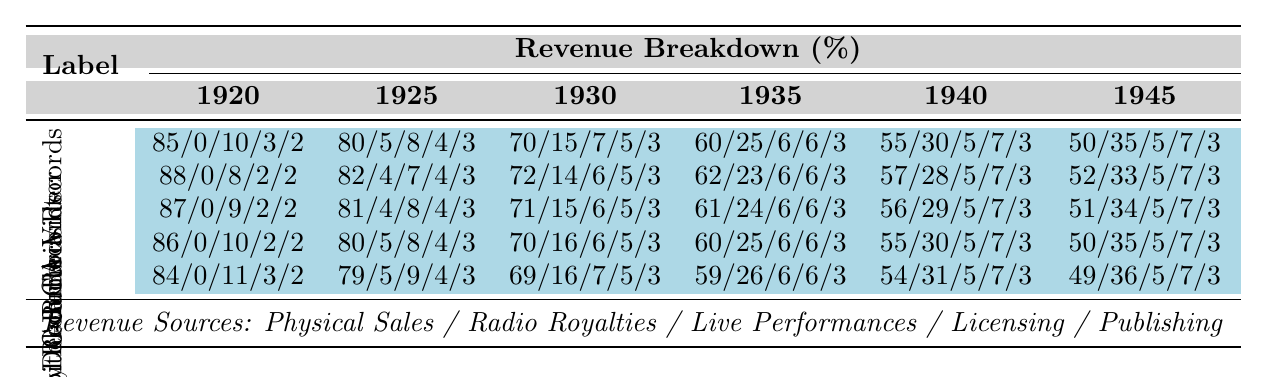What was the revenue percentage from Radio Royalties for Columbia Records in 1935? Columbia Records had a revenue breakdown of 60% from Physical Sales, 25% from Radio Royalties, 6% from Live Performances, 6% from Licensing, and 3% from Publishing in 1935. Specifically, the Radio Royalties percentage is 25%.
Answer: 25% Which record label had the highest percentage of revenue from Physical Sales in 1940? In 1940, Columbia Records had 55%, RCA Victor had 57%, Decca Records had 56%, Capitol Records had 55%, and Mercury Records had 54% from Physical Sales. RCA Victor had the highest percentage at 57%.
Answer: RCA Victor What percentage of revenue did Decca Records earn from Publishing in 1945? In 1945, Decca Records had a revenue breakdown of 51% Physical Sales, 34% Radio Royalties, 5% Live Performances, 7% Licensing, and 3% Publishing. The percentage from Publishing is 3%.
Answer: 3% Did the percentage of revenue from Radio Royalties increase for any record label from 1920 to 1945? Analyzing the data, each record label shows an increase in the percentage from Radio Royalties over the years, rising from 0% in 1920 for Columbia, RCA, Decca, Capitol, and Mercury to 35%, 33%, 34%, 35%, and 36% respectively in 1945. Therefore, yes, Radio Royalties increased for all.
Answer: Yes What was the average percentage of revenue from Live Performances across all record labels in 1940? In 1940, the Live Performances percentages for each label are: Columbia (5%), RCA Victor (5%), Decca Records (5%), Capitol Records (5%), and Mercury Records (5%). Adding these gives a total of 25%. Dividing by the number of labels (5) gives the average as 25% / 5 = 5%.
Answer: 5% Which label had the smallest share of revenue from Licensing in 1940? In 1940, the percentages for Licensing were: Columbia (7%), RCA Victor (7%), Decca (7%), Capitol (7%), and Mercury (7%). All labels had the same percentage from Licensing. Thus, no label had a smaller share.
Answer: None (all equal) How much did the total revenue from Radio Royalties change for Columbia Records from 1930 to 1940? Columbia Records had a revenue percentage from Radio Royalties of 15% in 1930 and 30% in 1940. The change can be calculated by subtracting the earlier percentage from the later one: 30% - 15% = 15%.
Answer: 15% What percentage growth in Radio Royalties did RCA Victor experience from 1930 to 1945? RCA Victor's Radio Royalties increased from 14% in 1930 to 33% in 1945. The growth is found by subtracting the earlier percentage from the later: 33% - 14% = 19%.
Answer: 19% Which record label has the least variation in percentage of revenue from Live Performances over the years? Looking at the data, all labels show a consistent 5% revenue from Live Performances in 1940 and 1945. The variation for each label across the years does not exceed this consistency. Thus, any label could be said to have this stable amount.
Answer: All labels have equal stability in Live Performances 